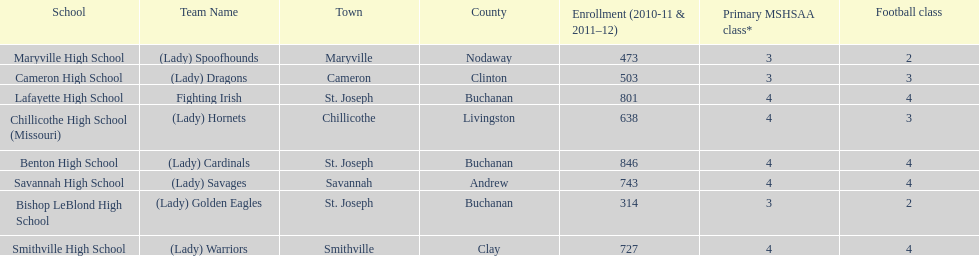Does lafayette high school or benton high school have green and grey as their colors? Lafayette High School. 